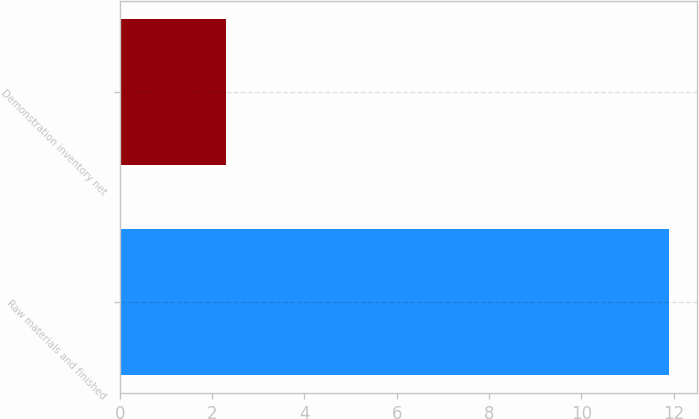Convert chart. <chart><loc_0><loc_0><loc_500><loc_500><bar_chart><fcel>Raw materials and finished<fcel>Demonstration inventory net<nl><fcel>11.9<fcel>2.3<nl></chart> 